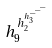Convert formula to latex. <formula><loc_0><loc_0><loc_500><loc_500>h _ { 9 } ^ { h _ { 2 } ^ { h _ { 3 } ^ { - ^ { - ^ { - } } } } }</formula> 